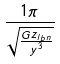<formula> <loc_0><loc_0><loc_500><loc_500>\frac { 1 \pi } { \sqrt { \frac { G z _ { l b n } } { y ^ { 3 } } } }</formula> 